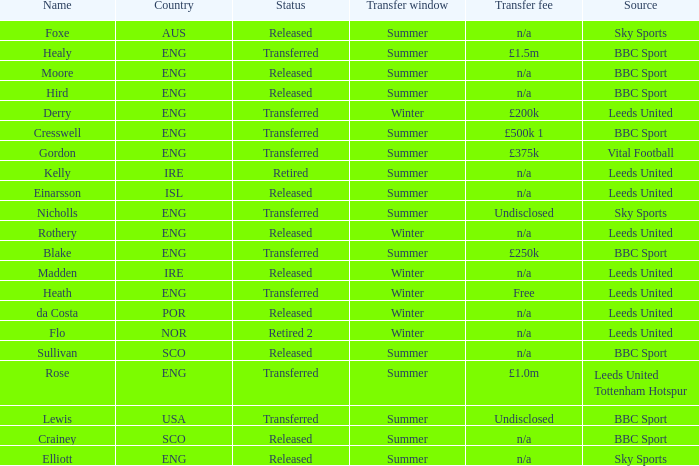What was the source for the person named Cresswell? BBC Sport. 